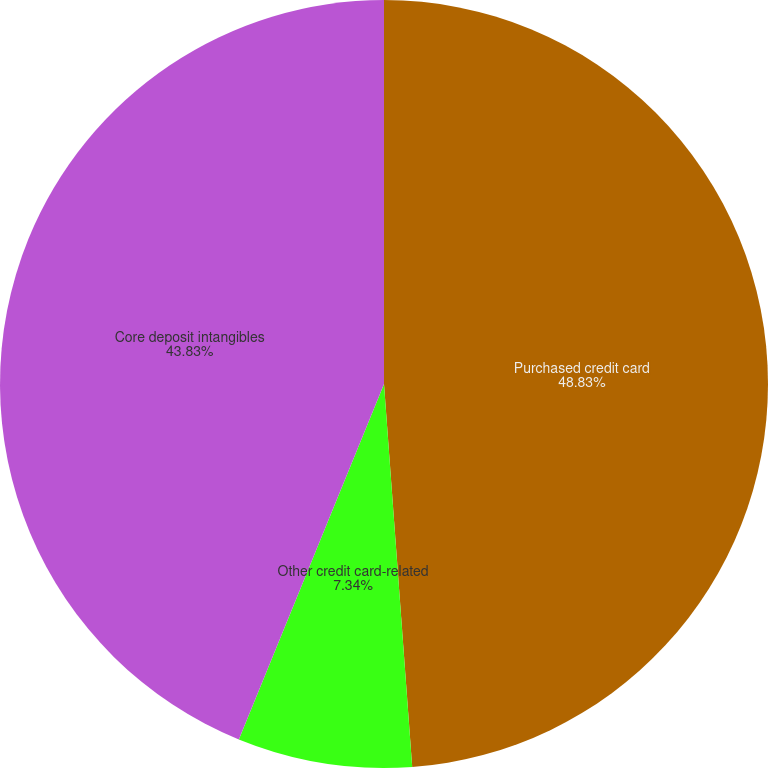Convert chart to OTSL. <chart><loc_0><loc_0><loc_500><loc_500><pie_chart><fcel>Purchased credit card<fcel>Other credit card-related<fcel>Core deposit intangibles<nl><fcel>48.83%<fcel>7.34%<fcel>43.83%<nl></chart> 